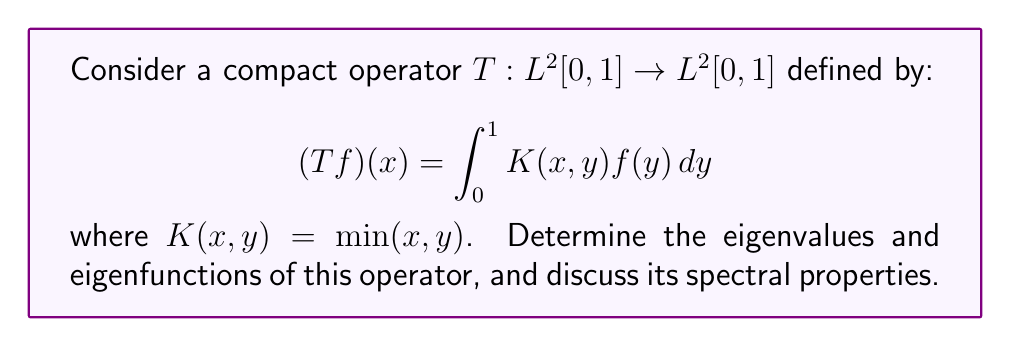Give your solution to this math problem. To analyze the spectral properties of this compact operator, we'll follow these steps:

1) First, we need to find the eigenvalues and eigenfunctions. Let $\lambda$ be an eigenvalue and $f$ be the corresponding eigenfunction. Then:

   $$\lambda f(x) = \int_0^1 \min(x,y)f(y)dy$$

2) Differentiating both sides with respect to x:

   $$\lambda f'(x) = \int_x^1 f(y)dy$$

3) Differentiating again:

   $$\lambda f''(x) = -f(x)$$

4) This is a second-order differential equation. The general solution is:

   $$f(x) = A\sin(\frac{x}{\sqrt{\lambda}}) + B\cos(\frac{x}{\sqrt{\lambda}})$$

5) Using the boundary conditions:
   
   At $x=0$: $f(0) = 0$, so $B = 0$
   At $x=1$: $f'(1) = 0$ (from step 2), so $\cos(\frac{1}{\sqrt{\lambda}}) = 0$

6) This gives us the eigenvalues:

   $$\lambda_n = \frac{4}{(2n-1)^2\pi^2}, \quad n = 1,2,3,...$$

7) The corresponding normalized eigenfunctions are:

   $$f_n(x) = \sqrt{2}\sin(\frac{(2n-1)\pi x}{2})$$

8) Spectral properties:
   - The eigenvalues form a decreasing sequence converging to 0.
   - The operator is compact (given in the problem).
   - The spectrum consists only of these eigenvalues and 0.
   - The operator is self-adjoint (symmetric kernel).
   - The eigenfunctions form an orthonormal basis for $L^2[0,1]$.

9) The spectral decomposition of T is:

   $$T = \sum_{n=1}^{\infty} \frac{4}{(2n-1)^2\pi^2} (\cdot, f_n)f_n$$

   where $(\cdot, f_n)$ denotes the inner product with $f_n$.
Answer: The eigenvalues are $\lambda_n = \frac{4}{(2n-1)^2\pi^2}$ for $n = 1,2,3,...$, and the corresponding normalized eigenfunctions are $f_n(x) = \sqrt{2}\sin(\frac{(2n-1)\pi x}{2})$. The operator is compact, self-adjoint, and has a purely discrete spectrum consisting of these eigenvalues and 0. 